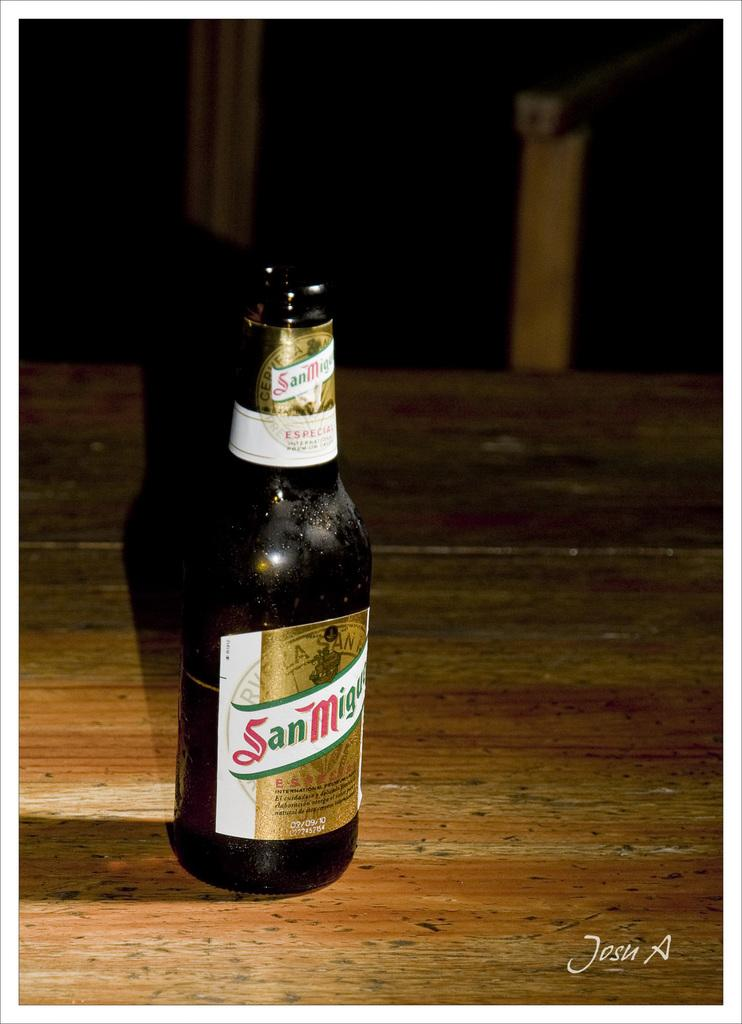Provide a one-sentence caption for the provided image. An opened bottle of San Miguel sits on a wooden table. 